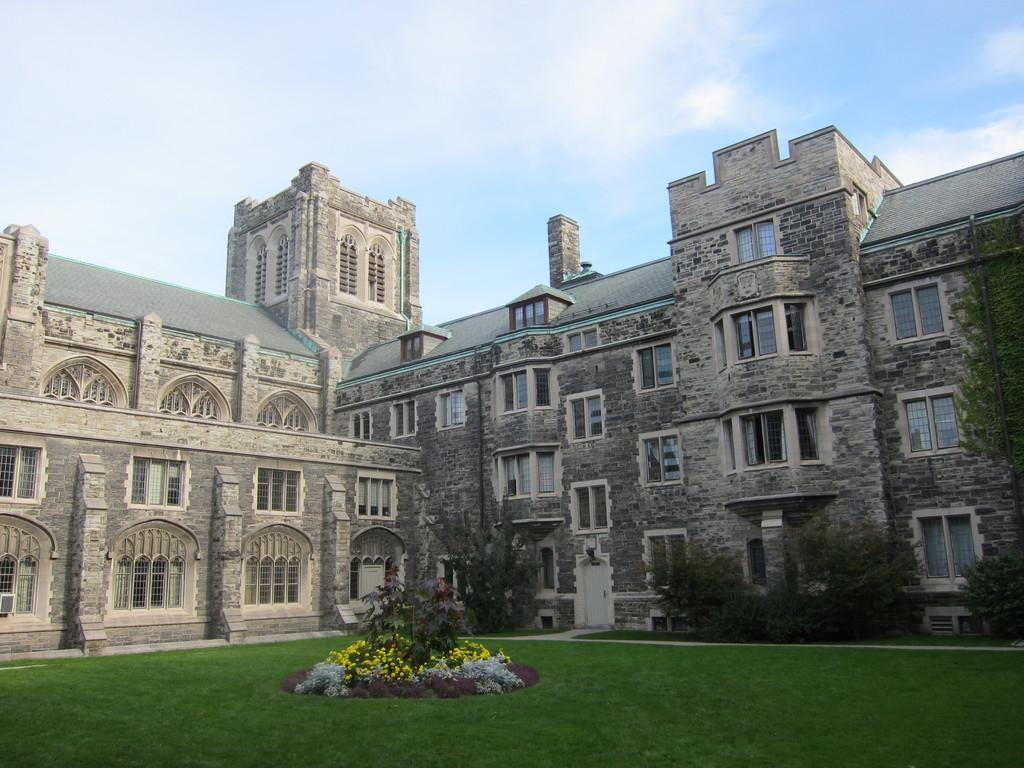What type of structure is in the image? There is a building in the image. What is located in front of the building? There are trees, flowers, and plants in front of the building. Can you describe the surface in front of the building? The surface of the grass is visible. What is visible in the background of the image? The sky is visible in the background of the image. Where is the lunchroom located in the image? There is no lunchroom present in the image. What type of appliance can be seen in the image? There are no appliances visible in the image. 